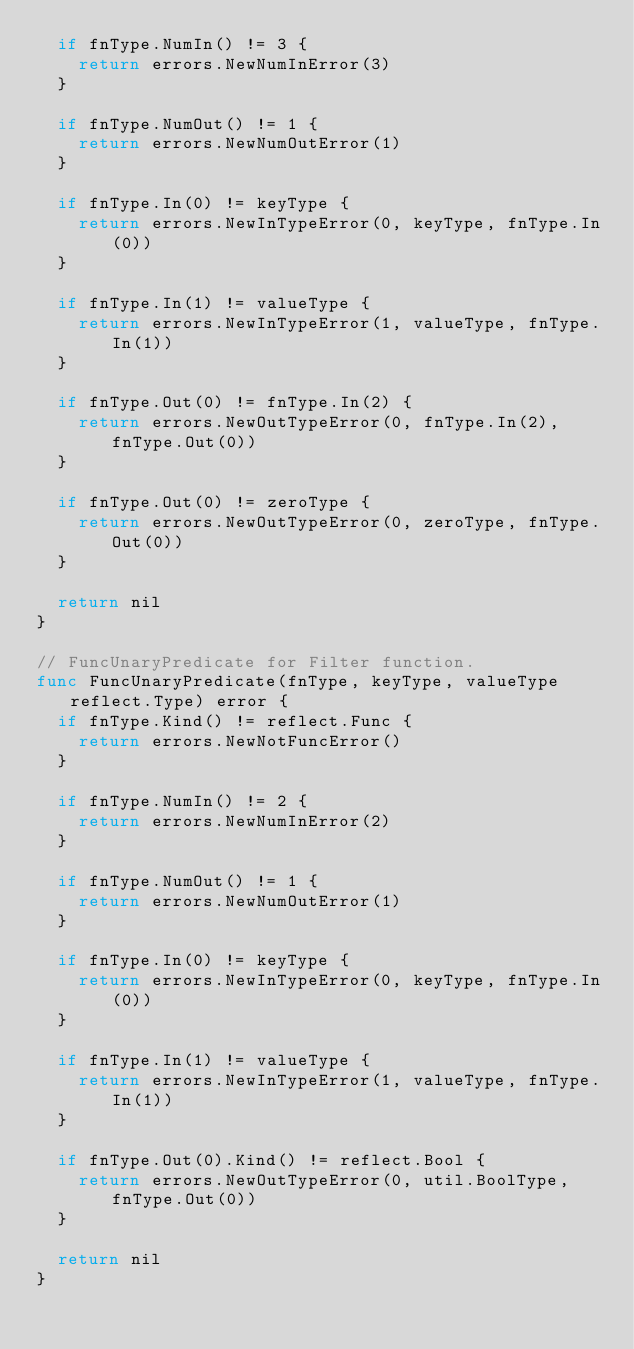Convert code to text. <code><loc_0><loc_0><loc_500><loc_500><_Go_>	if fnType.NumIn() != 3 {
		return errors.NewNumInError(3)
	}

	if fnType.NumOut() != 1 {
		return errors.NewNumOutError(1)
	}

	if fnType.In(0) != keyType {
		return errors.NewInTypeError(0, keyType, fnType.In(0))
	}

	if fnType.In(1) != valueType {
		return errors.NewInTypeError(1, valueType, fnType.In(1))
	}

	if fnType.Out(0) != fnType.In(2) {
		return errors.NewOutTypeError(0, fnType.In(2), fnType.Out(0))
	}

	if fnType.Out(0) != zeroType {
		return errors.NewOutTypeError(0, zeroType, fnType.Out(0))
	}

	return nil
}

// FuncUnaryPredicate for Filter function.
func FuncUnaryPredicate(fnType, keyType, valueType reflect.Type) error {
	if fnType.Kind() != reflect.Func {
		return errors.NewNotFuncError()
	}

	if fnType.NumIn() != 2 {
		return errors.NewNumInError(2)
	}

	if fnType.NumOut() != 1 {
		return errors.NewNumOutError(1)
	}

	if fnType.In(0) != keyType {
		return errors.NewInTypeError(0, keyType, fnType.In(0))
	}

	if fnType.In(1) != valueType {
		return errors.NewInTypeError(1, valueType, fnType.In(1))
	}

	if fnType.Out(0).Kind() != reflect.Bool {
		return errors.NewOutTypeError(0, util.BoolType, fnType.Out(0))
	}

	return nil
}
</code> 